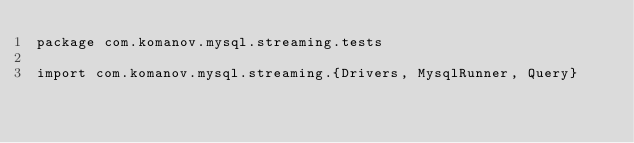Convert code to text. <code><loc_0><loc_0><loc_500><loc_500><_Scala_>package com.komanov.mysql.streaming.tests

import com.komanov.mysql.streaming.{Drivers, MysqlRunner, Query}
</code> 